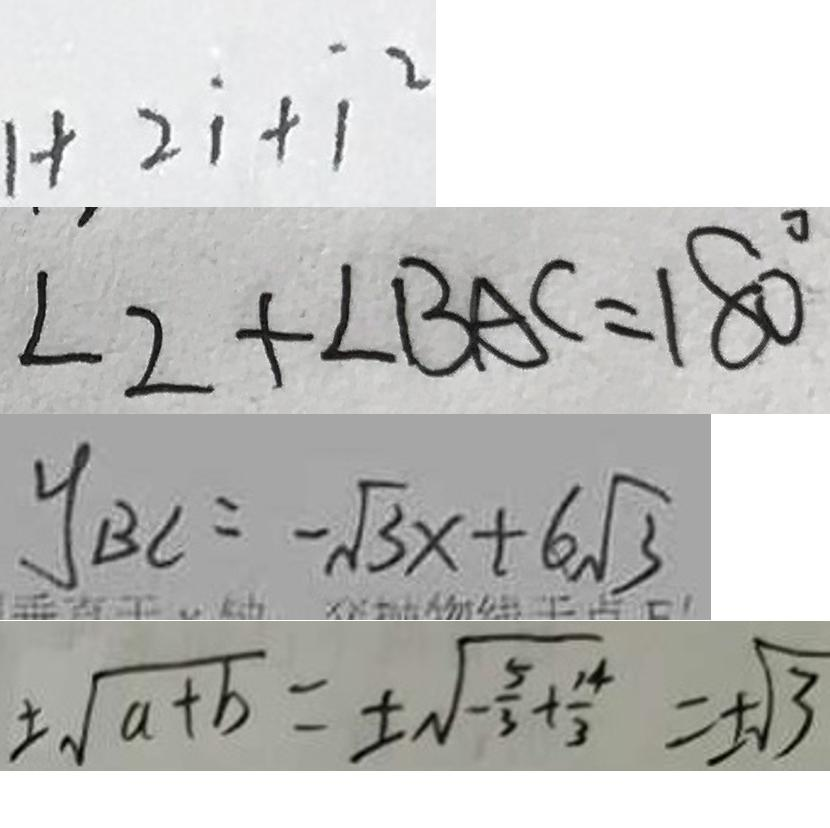<formula> <loc_0><loc_0><loc_500><loc_500>1 + 2 \dot { 1 } + \dot { 1 } ^ { 2 } 
 \angle 2 + \angle B A C = 1 8 0 ^ { \circ } 
 y _ { B C } = - \sqrt { 3 } x + 6 \sqrt { 3 } 
 \pm \sqrt { a + b } = \pm \sqrt { - \frac { 5 } { 3 } + \frac { 1 4 } { 3 } } = \pm \sqrt { 3 }</formula> 